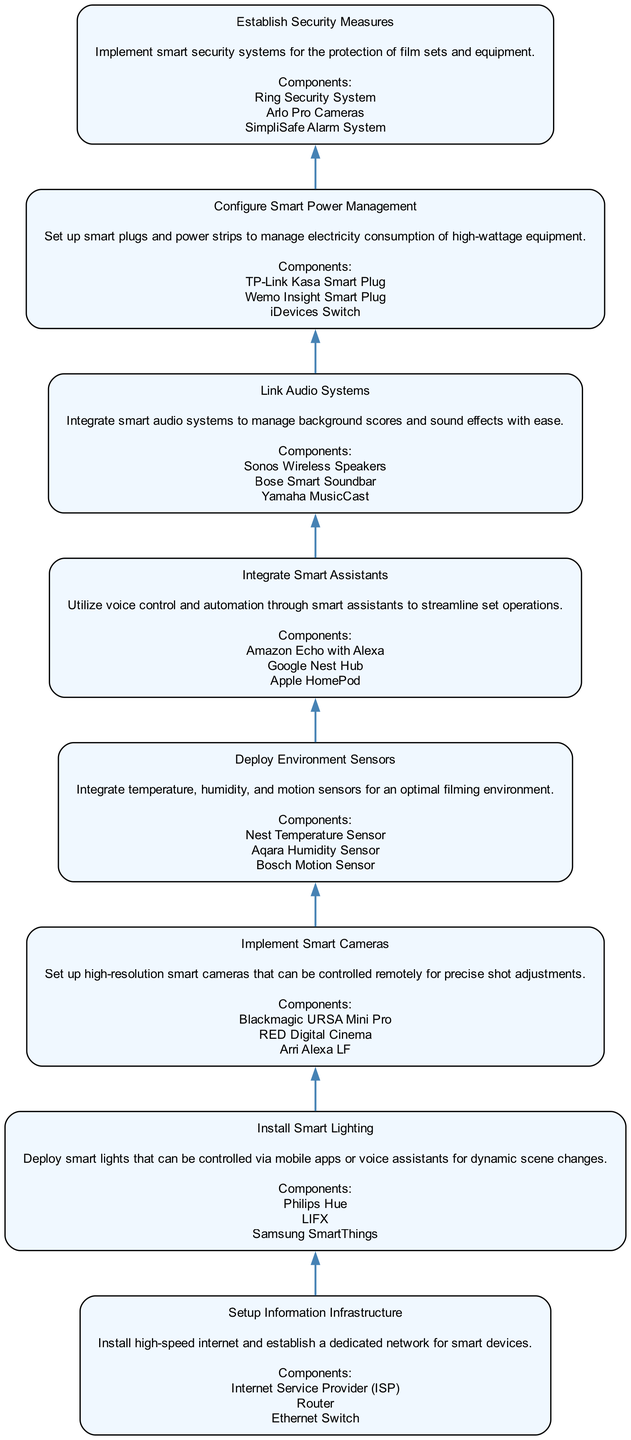What is the first stage in the diagram? The first stage is "Setup Information Infrastructure", which is positioned at the bottom of the diagram. This is the starting point before any other smart technology is integrated.
Answer: Setup Information Infrastructure How many components are listed under "Deploy Environment Sensors"? The section for "Deploy Environment Sensors" includes three components mentioned in the diagram: Nest Temperature Sensor, Aqara Humidity Sensor, and Bosch Motion Sensor. Therefore, the total count is three.
Answer: 3 What stage comes directly after "Install Smart Lighting"? The stage "Implement Smart Cameras" follows immediately after "Install Smart Lighting" in the flow of the diagram. This indicates a sequential step in the integration of smart technology for the film set.
Answer: Implement Smart Cameras Which smart device is mentioned for security measures? The diagram states that "Ring Security System" is one of the components listed under "Establish Security Measures". This indicates a technology used for protecting the film set and equipment.
Answer: Ring Security System What is the last stage in the diagram? The final stage is "Establish Security Measures", which appears at the top of the flow chart, representing the culmination of integrating various smart technologies for a secure film set.
Answer: Establish Security Measures What is the purpose of integrating smart power management? The purpose of "Configure Smart Power Management" is to manage electricity consumption of high-wattage equipment using smart plugs and power strips as indicated in the diagram. This shows the focus on energy efficiency and management.
Answer: Manage electricity consumption What nodes are directly connected to "Integrate Smart Assistants"? "Integrate Smart Assistants" has two connections: "Deploy Environment Sensors" below it and "Link Audio Systems" above it, showing its position in the flow of the instruction.
Answer: Deploy Environment Sensors, Link Audio Systems If a film set is ready to use smart cameras, which stage must be completed before? Before utilizing "Implement Smart Cameras," the prior stage, which is "Install Smart Lighting," must be completed, as indicated by the flow direction in the diagram.
Answer: Install Smart Lighting 